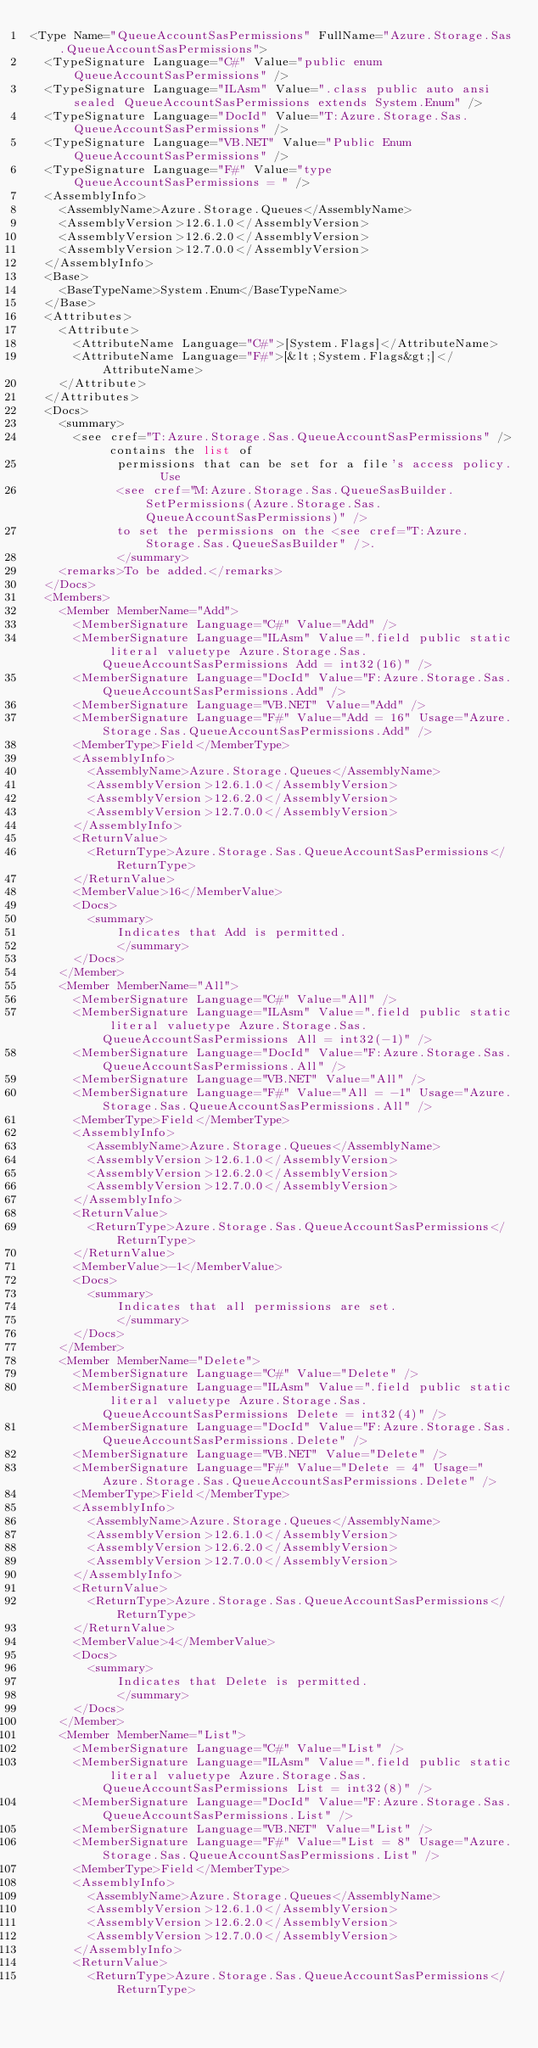Convert code to text. <code><loc_0><loc_0><loc_500><loc_500><_XML_><Type Name="QueueAccountSasPermissions" FullName="Azure.Storage.Sas.QueueAccountSasPermissions">
  <TypeSignature Language="C#" Value="public enum QueueAccountSasPermissions" />
  <TypeSignature Language="ILAsm" Value=".class public auto ansi sealed QueueAccountSasPermissions extends System.Enum" />
  <TypeSignature Language="DocId" Value="T:Azure.Storage.Sas.QueueAccountSasPermissions" />
  <TypeSignature Language="VB.NET" Value="Public Enum QueueAccountSasPermissions" />
  <TypeSignature Language="F#" Value="type QueueAccountSasPermissions = " />
  <AssemblyInfo>
    <AssemblyName>Azure.Storage.Queues</AssemblyName>
    <AssemblyVersion>12.6.1.0</AssemblyVersion>
    <AssemblyVersion>12.6.2.0</AssemblyVersion>
    <AssemblyVersion>12.7.0.0</AssemblyVersion>
  </AssemblyInfo>
  <Base>
    <BaseTypeName>System.Enum</BaseTypeName>
  </Base>
  <Attributes>
    <Attribute>
      <AttributeName Language="C#">[System.Flags]</AttributeName>
      <AttributeName Language="F#">[&lt;System.Flags&gt;]</AttributeName>
    </Attribute>
  </Attributes>
  <Docs>
    <summary>
      <see cref="T:Azure.Storage.Sas.QueueAccountSasPermissions" /> contains the list of
            permissions that can be set for a file's access policy.  Use
            <see cref="M:Azure.Storage.Sas.QueueSasBuilder.SetPermissions(Azure.Storage.Sas.QueueAccountSasPermissions)" />
            to set the permissions on the <see cref="T:Azure.Storage.Sas.QueueSasBuilder" />.
            </summary>
    <remarks>To be added.</remarks>
  </Docs>
  <Members>
    <Member MemberName="Add">
      <MemberSignature Language="C#" Value="Add" />
      <MemberSignature Language="ILAsm" Value=".field public static literal valuetype Azure.Storage.Sas.QueueAccountSasPermissions Add = int32(16)" />
      <MemberSignature Language="DocId" Value="F:Azure.Storage.Sas.QueueAccountSasPermissions.Add" />
      <MemberSignature Language="VB.NET" Value="Add" />
      <MemberSignature Language="F#" Value="Add = 16" Usage="Azure.Storage.Sas.QueueAccountSasPermissions.Add" />
      <MemberType>Field</MemberType>
      <AssemblyInfo>
        <AssemblyName>Azure.Storage.Queues</AssemblyName>
        <AssemblyVersion>12.6.1.0</AssemblyVersion>
        <AssemblyVersion>12.6.2.0</AssemblyVersion>
        <AssemblyVersion>12.7.0.0</AssemblyVersion>
      </AssemblyInfo>
      <ReturnValue>
        <ReturnType>Azure.Storage.Sas.QueueAccountSasPermissions</ReturnType>
      </ReturnValue>
      <MemberValue>16</MemberValue>
      <Docs>
        <summary>
            Indicates that Add is permitted.
            </summary>
      </Docs>
    </Member>
    <Member MemberName="All">
      <MemberSignature Language="C#" Value="All" />
      <MemberSignature Language="ILAsm" Value=".field public static literal valuetype Azure.Storage.Sas.QueueAccountSasPermissions All = int32(-1)" />
      <MemberSignature Language="DocId" Value="F:Azure.Storage.Sas.QueueAccountSasPermissions.All" />
      <MemberSignature Language="VB.NET" Value="All" />
      <MemberSignature Language="F#" Value="All = -1" Usage="Azure.Storage.Sas.QueueAccountSasPermissions.All" />
      <MemberType>Field</MemberType>
      <AssemblyInfo>
        <AssemblyName>Azure.Storage.Queues</AssemblyName>
        <AssemblyVersion>12.6.1.0</AssemblyVersion>
        <AssemblyVersion>12.6.2.0</AssemblyVersion>
        <AssemblyVersion>12.7.0.0</AssemblyVersion>
      </AssemblyInfo>
      <ReturnValue>
        <ReturnType>Azure.Storage.Sas.QueueAccountSasPermissions</ReturnType>
      </ReturnValue>
      <MemberValue>-1</MemberValue>
      <Docs>
        <summary>
            Indicates that all permissions are set.
            </summary>
      </Docs>
    </Member>
    <Member MemberName="Delete">
      <MemberSignature Language="C#" Value="Delete" />
      <MemberSignature Language="ILAsm" Value=".field public static literal valuetype Azure.Storage.Sas.QueueAccountSasPermissions Delete = int32(4)" />
      <MemberSignature Language="DocId" Value="F:Azure.Storage.Sas.QueueAccountSasPermissions.Delete" />
      <MemberSignature Language="VB.NET" Value="Delete" />
      <MemberSignature Language="F#" Value="Delete = 4" Usage="Azure.Storage.Sas.QueueAccountSasPermissions.Delete" />
      <MemberType>Field</MemberType>
      <AssemblyInfo>
        <AssemblyName>Azure.Storage.Queues</AssemblyName>
        <AssemblyVersion>12.6.1.0</AssemblyVersion>
        <AssemblyVersion>12.6.2.0</AssemblyVersion>
        <AssemblyVersion>12.7.0.0</AssemblyVersion>
      </AssemblyInfo>
      <ReturnValue>
        <ReturnType>Azure.Storage.Sas.QueueAccountSasPermissions</ReturnType>
      </ReturnValue>
      <MemberValue>4</MemberValue>
      <Docs>
        <summary>
            Indicates that Delete is permitted.
            </summary>
      </Docs>
    </Member>
    <Member MemberName="List">
      <MemberSignature Language="C#" Value="List" />
      <MemberSignature Language="ILAsm" Value=".field public static literal valuetype Azure.Storage.Sas.QueueAccountSasPermissions List = int32(8)" />
      <MemberSignature Language="DocId" Value="F:Azure.Storage.Sas.QueueAccountSasPermissions.List" />
      <MemberSignature Language="VB.NET" Value="List" />
      <MemberSignature Language="F#" Value="List = 8" Usage="Azure.Storage.Sas.QueueAccountSasPermissions.List" />
      <MemberType>Field</MemberType>
      <AssemblyInfo>
        <AssemblyName>Azure.Storage.Queues</AssemblyName>
        <AssemblyVersion>12.6.1.0</AssemblyVersion>
        <AssemblyVersion>12.6.2.0</AssemblyVersion>
        <AssemblyVersion>12.7.0.0</AssemblyVersion>
      </AssemblyInfo>
      <ReturnValue>
        <ReturnType>Azure.Storage.Sas.QueueAccountSasPermissions</ReturnType></code> 